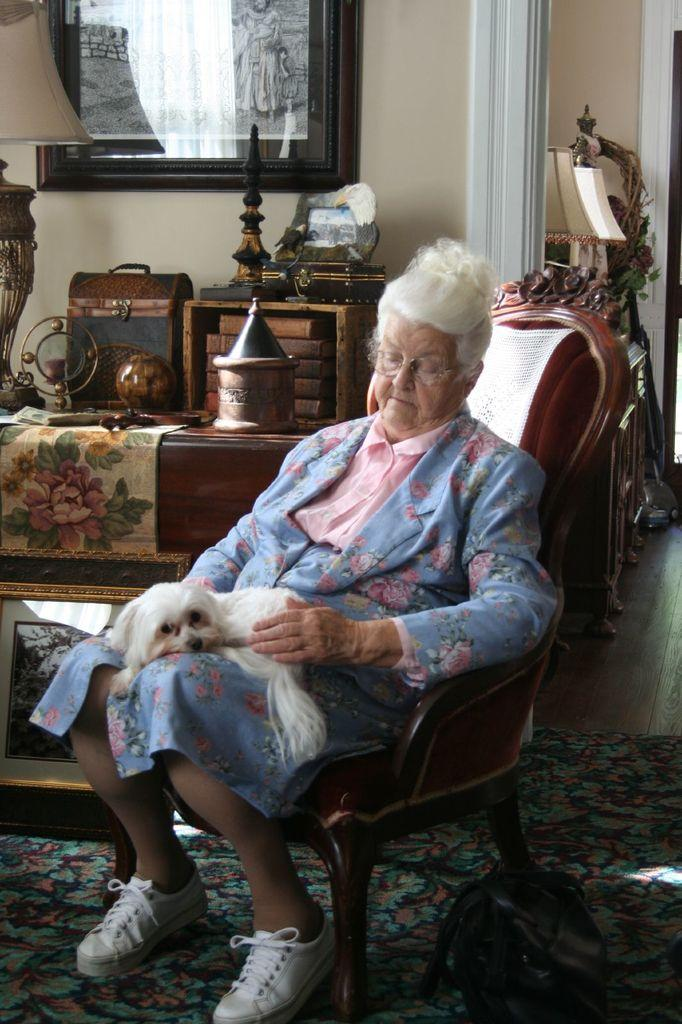Who is the main subject in the image? There is a lady in the image. What is the lady wearing? The lady is wearing a pink and blue dress. What is the lady doing in the image? The lady is sitting on a chair. What is in the lady's lap? There is a dog in the lady's lap. What can be seen in the background of the image? There is a desk in the background of the image. What is on the desk? There are items placed on the desk. What type of bird is flying over the lady's head in the image? There is no bird flying over the lady's head in the image. Can you tell me how many pigs are present in the image? There are no pigs present in the image. 